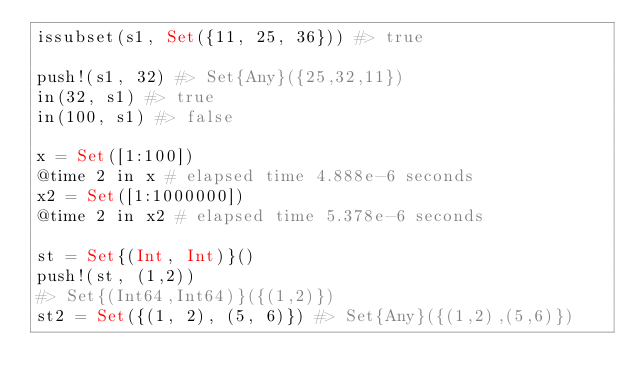Convert code to text. <code><loc_0><loc_0><loc_500><loc_500><_Julia_>issubset(s1, Set({11, 25, 36})) #> true

push!(s1, 32) #> Set{Any}({25,32,11})
in(32, s1) #> true
in(100, s1) #> false

x = Set([1:100])
@time 2 in x # elapsed time 4.888e-6 seconds
x2 = Set([1:1000000])
@time 2 in x2 # elapsed time 5.378e-6 seconds

st = Set{(Int, Int)}()
push!(st, (1,2))
#> Set{(Int64,Int64)}({(1,2)})
st2 = Set({(1, 2), (5, 6)}) #> Set{Any}({(1,2),(5,6)})</code> 